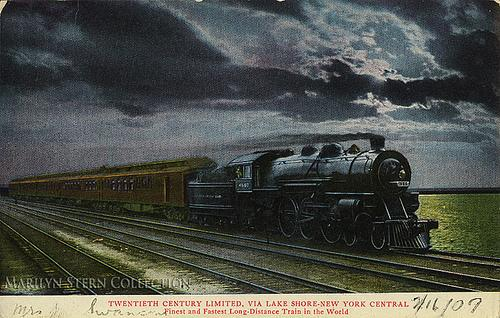Describe the color and type of the passenger cars in the image. The passenger cars are yellow and long, designed for carrying passengers. What type of transport is depicted in the image and what color is it? The image shows a black train moving along its tracks. In a product advertisement task, what aspect of the image could be emphasized to attract potential customers? The nostalgic atmosphere of the image, showcasing a historic train and scenic backdrop, could be emphasized to attract customers. Identify the primary object in the image and the action it is performing. A black train engine is moving along the train tracks with a long brown passenger car in tow. For the multi-choice VQA task, give a brief summary of the main subject of the image. The image shows an old black train engine and a long yellow passenger car moving along the train tracks. For the visual entailment task, describe what can be inferred about the time or weather in the image. The image shows a dark and cloudy sky, suggesting that it's either early morning, late evening, or an overcast day. Provide a brief description of the setting and atmosphere of the image. The image shows a train traveling through a green field under a dark and cloudy sky, creating a dramatic and nostalgic atmosphere. Determine the type of environment the main subject is located in and describe it. The train is passing through a green field with a dark and cloudy sky overhead, giving a sense of a cloudy day. 